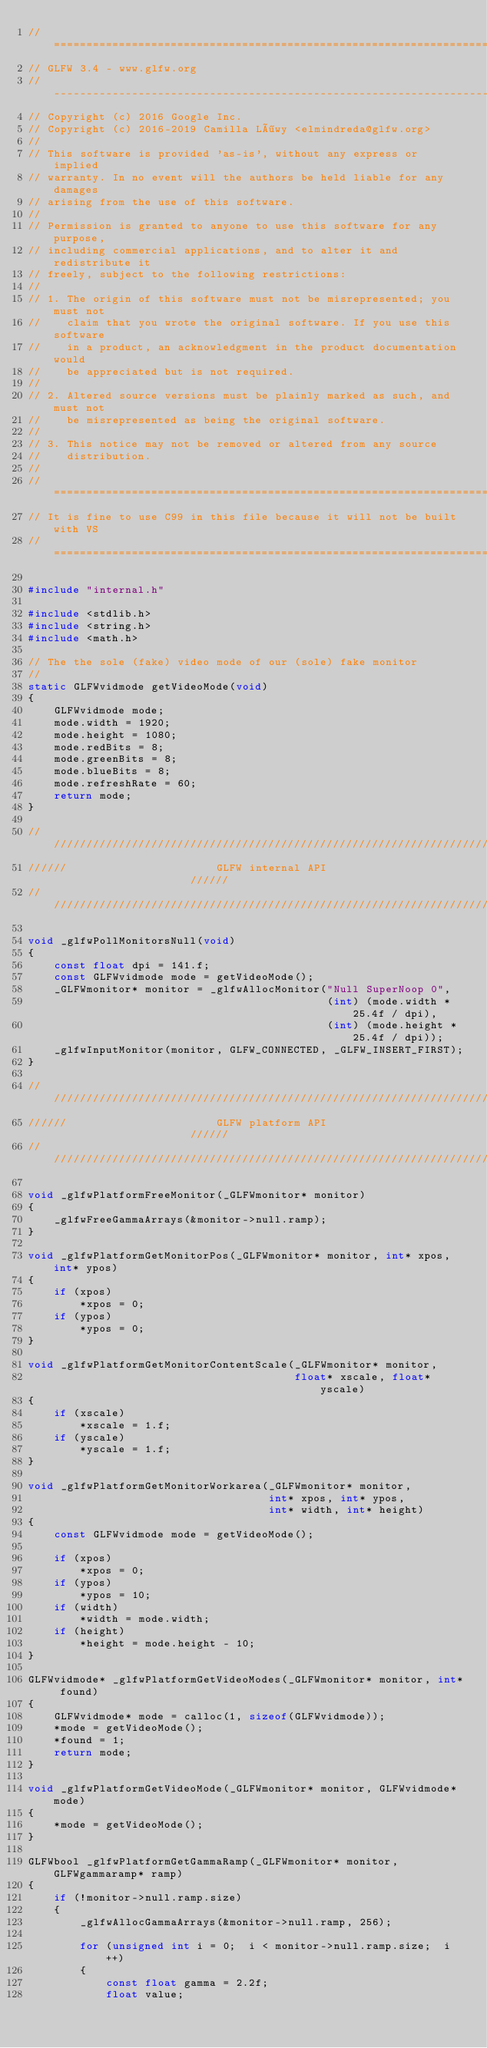Convert code to text. <code><loc_0><loc_0><loc_500><loc_500><_C_>//========================================================================
// GLFW 3.4 - www.glfw.org
//------------------------------------------------------------------------
// Copyright (c) 2016 Google Inc.
// Copyright (c) 2016-2019 Camilla Löwy <elmindreda@glfw.org>
//
// This software is provided 'as-is', without any express or implied
// warranty. In no event will the authors be held liable for any damages
// arising from the use of this software.
//
// Permission is granted to anyone to use this software for any purpose,
// including commercial applications, and to alter it and redistribute it
// freely, subject to the following restrictions:
//
// 1. The origin of this software must not be misrepresented; you must not
//    claim that you wrote the original software. If you use this software
//    in a product, an acknowledgment in the product documentation would
//    be appreciated but is not required.
//
// 2. Altered source versions must be plainly marked as such, and must not
//    be misrepresented as being the original software.
//
// 3. This notice may not be removed or altered from any source
//    distribution.
//
//========================================================================
// It is fine to use C99 in this file because it will not be built with VS
//========================================================================

#include "internal.h"

#include <stdlib.h>
#include <string.h>
#include <math.h>

// The the sole (fake) video mode of our (sole) fake monitor
//
static GLFWvidmode getVideoMode(void)
{
    GLFWvidmode mode;
    mode.width = 1920;
    mode.height = 1080;
    mode.redBits = 8;
    mode.greenBits = 8;
    mode.blueBits = 8;
    mode.refreshRate = 60;
    return mode;
}

//////////////////////////////////////////////////////////////////////////
//////                       GLFW internal API                      //////
//////////////////////////////////////////////////////////////////////////

void _glfwPollMonitorsNull(void)
{
    const float dpi = 141.f;
    const GLFWvidmode mode = getVideoMode();
    _GLFWmonitor* monitor = _glfwAllocMonitor("Null SuperNoop 0",
                                              (int) (mode.width * 25.4f / dpi),
                                              (int) (mode.height * 25.4f / dpi));
    _glfwInputMonitor(monitor, GLFW_CONNECTED, _GLFW_INSERT_FIRST);
}

//////////////////////////////////////////////////////////////////////////
//////                       GLFW platform API                      //////
//////////////////////////////////////////////////////////////////////////

void _glfwPlatformFreeMonitor(_GLFWmonitor* monitor)
{
    _glfwFreeGammaArrays(&monitor->null.ramp);
}

void _glfwPlatformGetMonitorPos(_GLFWmonitor* monitor, int* xpos, int* ypos)
{
    if (xpos)
        *xpos = 0;
    if (ypos)
        *ypos = 0;
}

void _glfwPlatformGetMonitorContentScale(_GLFWmonitor* monitor,
                                         float* xscale, float* yscale)
{
    if (xscale)
        *xscale = 1.f;
    if (yscale)
        *yscale = 1.f;
}

void _glfwPlatformGetMonitorWorkarea(_GLFWmonitor* monitor,
                                     int* xpos, int* ypos,
                                     int* width, int* height)
{
    const GLFWvidmode mode = getVideoMode();

    if (xpos)
        *xpos = 0;
    if (ypos)
        *ypos = 10;
    if (width)
        *width = mode.width;
    if (height)
        *height = mode.height - 10;
}

GLFWvidmode* _glfwPlatformGetVideoModes(_GLFWmonitor* monitor, int* found)
{
    GLFWvidmode* mode = calloc(1, sizeof(GLFWvidmode));
    *mode = getVideoMode();
    *found = 1;
    return mode;
}

void _glfwPlatformGetVideoMode(_GLFWmonitor* monitor, GLFWvidmode* mode)
{
    *mode = getVideoMode();
}

GLFWbool _glfwPlatformGetGammaRamp(_GLFWmonitor* monitor, GLFWgammaramp* ramp)
{
    if (!monitor->null.ramp.size)
    {
        _glfwAllocGammaArrays(&monitor->null.ramp, 256);

        for (unsigned int i = 0;  i < monitor->null.ramp.size;  i++)
        {
            const float gamma = 2.2f;
            float value;</code> 